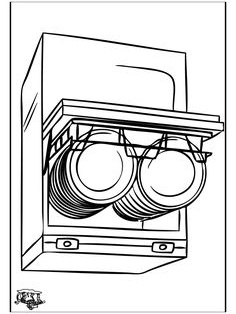What maintenance or common issues should one be aware of for the appliance shown? Regular maintenance for the dishwasher shown in the image includes cleaning the filter to prevent clogs, checking and cleaning the spray arms, and occasionally using a dishwasher cleaner to remove grease and lime scale buildup. Common issues might include ineffective cleaning if the appliance is overloaded, water leaks, or the dishwasher failing to start due to electrical problems or a malfunctioning door latch. 